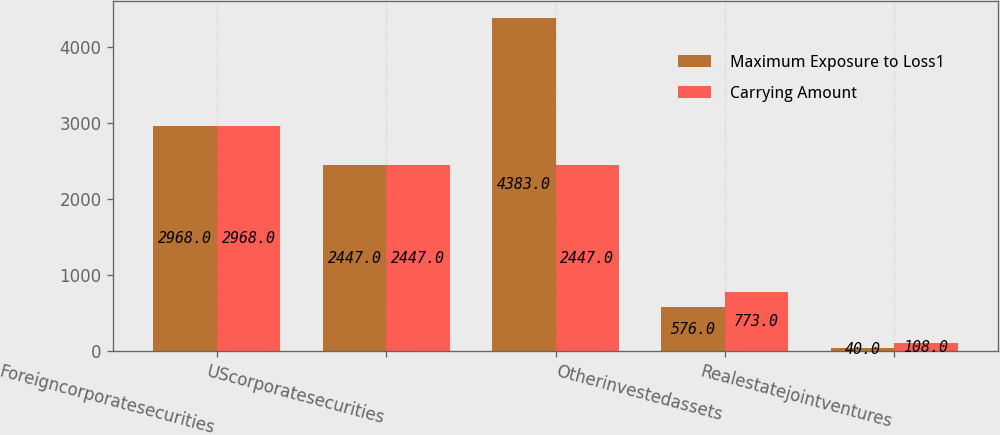<chart> <loc_0><loc_0><loc_500><loc_500><stacked_bar_chart><ecel><fcel>Foreigncorporatesecurities<fcel>UScorporatesecurities<fcel>Unnamed: 3<fcel>Otherinvestedassets<fcel>Realestatejointventures<nl><fcel>Maximum Exposure to Loss1<fcel>2968<fcel>2447<fcel>4383<fcel>576<fcel>40<nl><fcel>Carrying Amount<fcel>2968<fcel>2447<fcel>2447<fcel>773<fcel>108<nl></chart> 